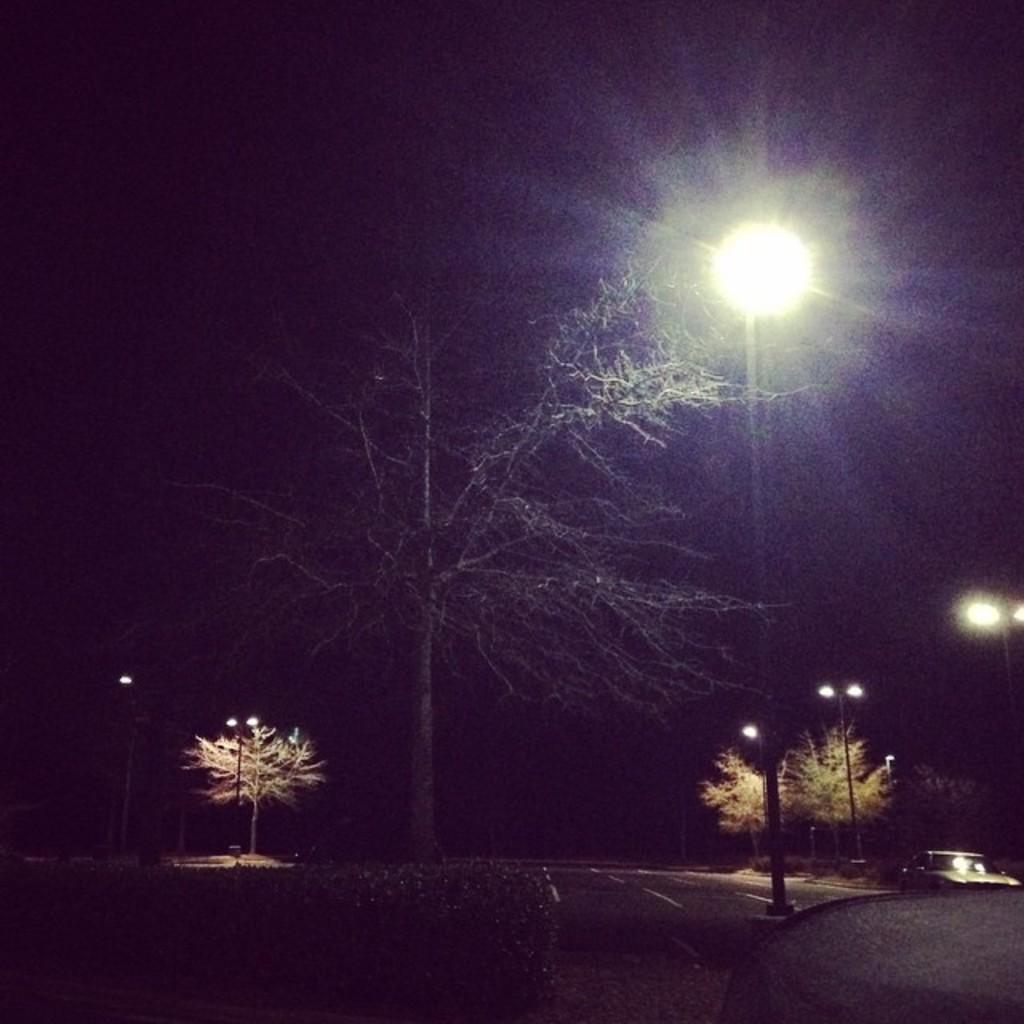Describe this image in one or two sentences. There is a road, near a divider, on which, there is a pole, which is having light. In the background, there are lights attached to the poles, there are trees. And the background is dark in color. 